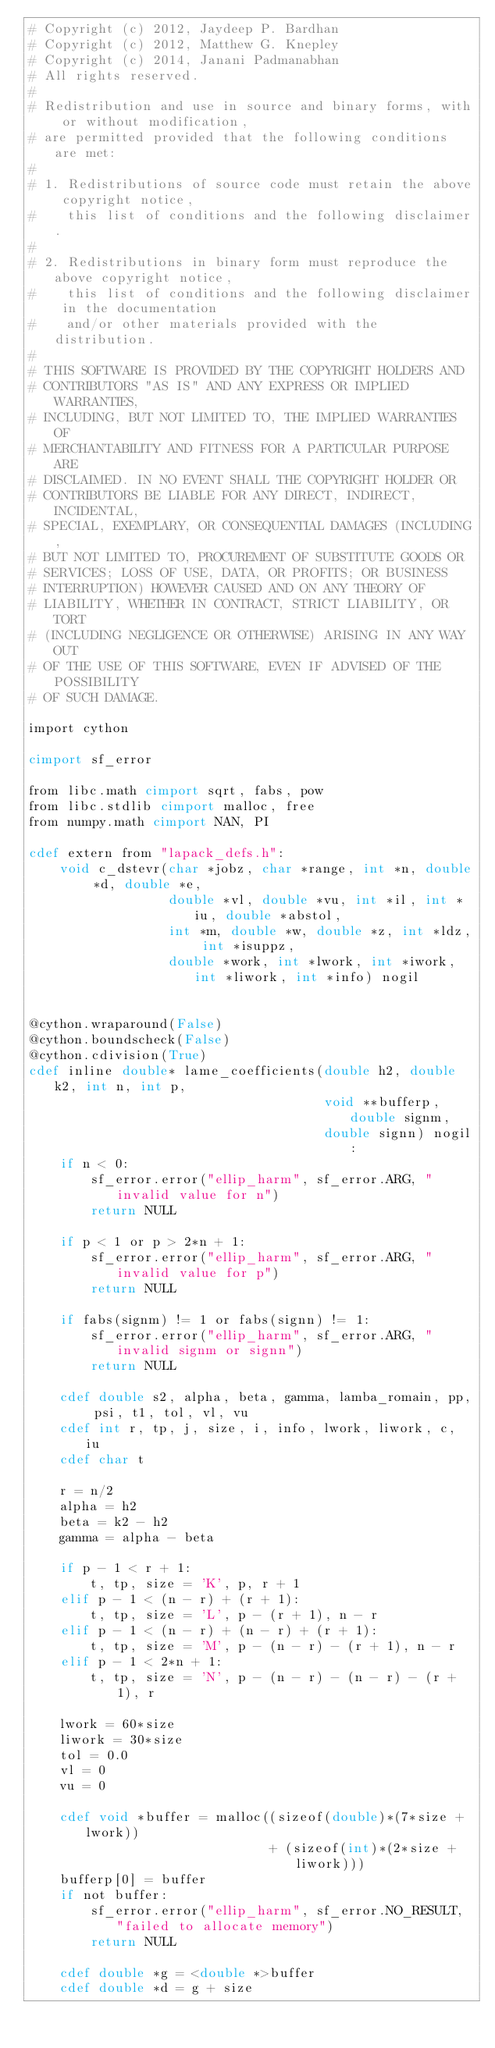Convert code to text. <code><loc_0><loc_0><loc_500><loc_500><_Cython_># Copyright (c) 2012, Jaydeep P. Bardhan
# Copyright (c) 2012, Matthew G. Knepley
# Copyright (c) 2014, Janani Padmanabhan
# All rights reserved.
#
# Redistribution and use in source and binary forms, with or without modification,
# are permitted provided that the following conditions are met:
#
# 1. Redistributions of source code must retain the above copyright notice,
#    this list of conditions and the following disclaimer.
#
# 2. Redistributions in binary form must reproduce the above copyright notice,
#    this list of conditions and the following disclaimer in the documentation
#    and/or other materials provided with the distribution.
#
# THIS SOFTWARE IS PROVIDED BY THE COPYRIGHT HOLDERS AND
# CONTRIBUTORS "AS IS" AND ANY EXPRESS OR IMPLIED WARRANTIES,
# INCLUDING, BUT NOT LIMITED TO, THE IMPLIED WARRANTIES OF
# MERCHANTABILITY AND FITNESS FOR A PARTICULAR PURPOSE ARE
# DISCLAIMED. IN NO EVENT SHALL THE COPYRIGHT HOLDER OR
# CONTRIBUTORS BE LIABLE FOR ANY DIRECT, INDIRECT, INCIDENTAL,
# SPECIAL, EXEMPLARY, OR CONSEQUENTIAL DAMAGES (INCLUDING,
# BUT NOT LIMITED TO, PROCUREMENT OF SUBSTITUTE GOODS OR
# SERVICES; LOSS OF USE, DATA, OR PROFITS; OR BUSINESS
# INTERRUPTION) HOWEVER CAUSED AND ON ANY THEORY OF
# LIABILITY, WHETHER IN CONTRACT, STRICT LIABILITY, OR TORT
# (INCLUDING NEGLIGENCE OR OTHERWISE) ARISING IN ANY WAY OUT
# OF THE USE OF THIS SOFTWARE, EVEN IF ADVISED OF THE POSSIBILITY
# OF SUCH DAMAGE.

import cython

cimport sf_error

from libc.math cimport sqrt, fabs, pow
from libc.stdlib cimport malloc, free
from numpy.math cimport NAN, PI

cdef extern from "lapack_defs.h":
    void c_dstevr(char *jobz, char *range, int *n, double *d, double *e,
                  double *vl, double *vu, int *il, int *iu, double *abstol,
                  int *m, double *w, double *z, int *ldz, int *isuppz,
                  double *work, int *lwork, int *iwork, int *liwork, int *info) nogil


@cython.wraparound(False)
@cython.boundscheck(False)
@cython.cdivision(True)
cdef inline double* lame_coefficients(double h2, double k2, int n, int p,
                                      void **bufferp, double signm,
                                      double signn) nogil:
    if n < 0:
        sf_error.error("ellip_harm", sf_error.ARG, "invalid value for n")
        return NULL

    if p < 1 or p > 2*n + 1:
        sf_error.error("ellip_harm", sf_error.ARG, "invalid value for p")
        return NULL

    if fabs(signm) != 1 or fabs(signn) != 1:
        sf_error.error("ellip_harm", sf_error.ARG, "invalid signm or signn")
        return NULL

    cdef double s2, alpha, beta, gamma, lamba_romain, pp, psi, t1, tol, vl, vu
    cdef int r, tp, j, size, i, info, lwork, liwork, c, iu
    cdef char t

    r = n/2
    alpha = h2
    beta = k2 - h2
    gamma = alpha - beta

    if p - 1 < r + 1:
        t, tp, size = 'K', p, r + 1
    elif p - 1 < (n - r) + (r + 1):
        t, tp, size = 'L', p - (r + 1), n - r
    elif p - 1 < (n - r) + (n - r) + (r + 1):
        t, tp, size = 'M', p - (n - r) - (r + 1), n - r
    elif p - 1 < 2*n + 1:
        t, tp, size = 'N', p - (n - r) - (n - r) - (r + 1), r

    lwork = 60*size
    liwork = 30*size
    tol = 0.0
    vl = 0
    vu = 0

    cdef void *buffer = malloc((sizeof(double)*(7*size + lwork))
                               + (sizeof(int)*(2*size + liwork)))
    bufferp[0] = buffer
    if not buffer:
        sf_error.error("ellip_harm", sf_error.NO_RESULT, "failed to allocate memory")
        return NULL

    cdef double *g = <double *>buffer
    cdef double *d = g + size</code> 